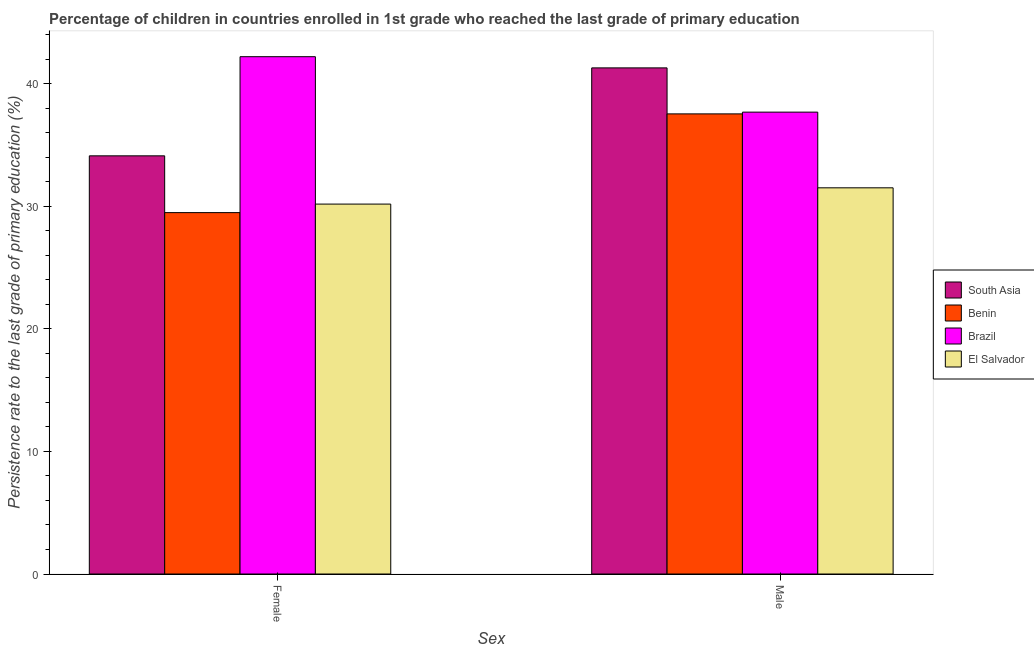Are the number of bars per tick equal to the number of legend labels?
Ensure brevity in your answer.  Yes. Are the number of bars on each tick of the X-axis equal?
Ensure brevity in your answer.  Yes. What is the label of the 2nd group of bars from the left?
Your answer should be compact. Male. What is the persistence rate of female students in El Salvador?
Provide a short and direct response. 30.19. Across all countries, what is the maximum persistence rate of male students?
Offer a terse response. 41.31. Across all countries, what is the minimum persistence rate of female students?
Provide a succinct answer. 29.5. In which country was the persistence rate of male students maximum?
Give a very brief answer. South Asia. In which country was the persistence rate of male students minimum?
Your answer should be compact. El Salvador. What is the total persistence rate of female students in the graph?
Provide a short and direct response. 136.04. What is the difference between the persistence rate of female students in Benin and that in Brazil?
Give a very brief answer. -12.73. What is the difference between the persistence rate of male students in Brazil and the persistence rate of female students in South Asia?
Give a very brief answer. 3.57. What is the average persistence rate of female students per country?
Provide a succinct answer. 34.01. What is the difference between the persistence rate of female students and persistence rate of male students in Brazil?
Keep it short and to the point. 4.53. In how many countries, is the persistence rate of female students greater than 26 %?
Give a very brief answer. 4. What is the ratio of the persistence rate of female students in South Asia to that in Benin?
Give a very brief answer. 1.16. In how many countries, is the persistence rate of male students greater than the average persistence rate of male students taken over all countries?
Your answer should be very brief. 3. What does the 4th bar from the right in Male represents?
Provide a succinct answer. South Asia. Are all the bars in the graph horizontal?
Your answer should be very brief. No. Are the values on the major ticks of Y-axis written in scientific E-notation?
Your response must be concise. No. Does the graph contain any zero values?
Your answer should be very brief. No. Does the graph contain grids?
Keep it short and to the point. No. How are the legend labels stacked?
Offer a very short reply. Vertical. What is the title of the graph?
Provide a short and direct response. Percentage of children in countries enrolled in 1st grade who reached the last grade of primary education. Does "Palau" appear as one of the legend labels in the graph?
Provide a succinct answer. No. What is the label or title of the X-axis?
Keep it short and to the point. Sex. What is the label or title of the Y-axis?
Make the answer very short. Persistence rate to the last grade of primary education (%). What is the Persistence rate to the last grade of primary education (%) of South Asia in Female?
Your answer should be very brief. 34.13. What is the Persistence rate to the last grade of primary education (%) of Benin in Female?
Your response must be concise. 29.5. What is the Persistence rate to the last grade of primary education (%) of Brazil in Female?
Offer a terse response. 42.22. What is the Persistence rate to the last grade of primary education (%) of El Salvador in Female?
Offer a terse response. 30.19. What is the Persistence rate to the last grade of primary education (%) in South Asia in Male?
Give a very brief answer. 41.31. What is the Persistence rate to the last grade of primary education (%) in Benin in Male?
Provide a short and direct response. 37.55. What is the Persistence rate to the last grade of primary education (%) of Brazil in Male?
Your response must be concise. 37.7. What is the Persistence rate to the last grade of primary education (%) of El Salvador in Male?
Offer a very short reply. 31.52. Across all Sex, what is the maximum Persistence rate to the last grade of primary education (%) of South Asia?
Ensure brevity in your answer.  41.31. Across all Sex, what is the maximum Persistence rate to the last grade of primary education (%) of Benin?
Offer a terse response. 37.55. Across all Sex, what is the maximum Persistence rate to the last grade of primary education (%) in Brazil?
Offer a terse response. 42.22. Across all Sex, what is the maximum Persistence rate to the last grade of primary education (%) in El Salvador?
Your response must be concise. 31.52. Across all Sex, what is the minimum Persistence rate to the last grade of primary education (%) of South Asia?
Keep it short and to the point. 34.13. Across all Sex, what is the minimum Persistence rate to the last grade of primary education (%) of Benin?
Your response must be concise. 29.5. Across all Sex, what is the minimum Persistence rate to the last grade of primary education (%) in Brazil?
Provide a short and direct response. 37.7. Across all Sex, what is the minimum Persistence rate to the last grade of primary education (%) of El Salvador?
Make the answer very short. 30.19. What is the total Persistence rate to the last grade of primary education (%) of South Asia in the graph?
Offer a terse response. 75.44. What is the total Persistence rate to the last grade of primary education (%) in Benin in the graph?
Give a very brief answer. 67.05. What is the total Persistence rate to the last grade of primary education (%) in Brazil in the graph?
Your response must be concise. 79.92. What is the total Persistence rate to the last grade of primary education (%) in El Salvador in the graph?
Your answer should be compact. 61.71. What is the difference between the Persistence rate to the last grade of primary education (%) in South Asia in Female and that in Male?
Ensure brevity in your answer.  -7.18. What is the difference between the Persistence rate to the last grade of primary education (%) in Benin in Female and that in Male?
Offer a very short reply. -8.06. What is the difference between the Persistence rate to the last grade of primary education (%) in Brazil in Female and that in Male?
Provide a short and direct response. 4.53. What is the difference between the Persistence rate to the last grade of primary education (%) in El Salvador in Female and that in Male?
Your answer should be compact. -1.33. What is the difference between the Persistence rate to the last grade of primary education (%) of South Asia in Female and the Persistence rate to the last grade of primary education (%) of Benin in Male?
Your answer should be compact. -3.42. What is the difference between the Persistence rate to the last grade of primary education (%) of South Asia in Female and the Persistence rate to the last grade of primary education (%) of Brazil in Male?
Provide a succinct answer. -3.57. What is the difference between the Persistence rate to the last grade of primary education (%) in South Asia in Female and the Persistence rate to the last grade of primary education (%) in El Salvador in Male?
Offer a very short reply. 2.61. What is the difference between the Persistence rate to the last grade of primary education (%) in Benin in Female and the Persistence rate to the last grade of primary education (%) in Brazil in Male?
Ensure brevity in your answer.  -8.2. What is the difference between the Persistence rate to the last grade of primary education (%) of Benin in Female and the Persistence rate to the last grade of primary education (%) of El Salvador in Male?
Keep it short and to the point. -2.02. What is the difference between the Persistence rate to the last grade of primary education (%) in Brazil in Female and the Persistence rate to the last grade of primary education (%) in El Salvador in Male?
Make the answer very short. 10.7. What is the average Persistence rate to the last grade of primary education (%) of South Asia per Sex?
Your response must be concise. 37.72. What is the average Persistence rate to the last grade of primary education (%) of Benin per Sex?
Ensure brevity in your answer.  33.53. What is the average Persistence rate to the last grade of primary education (%) in Brazil per Sex?
Provide a short and direct response. 39.96. What is the average Persistence rate to the last grade of primary education (%) of El Salvador per Sex?
Make the answer very short. 30.86. What is the difference between the Persistence rate to the last grade of primary education (%) in South Asia and Persistence rate to the last grade of primary education (%) in Benin in Female?
Keep it short and to the point. 4.63. What is the difference between the Persistence rate to the last grade of primary education (%) in South Asia and Persistence rate to the last grade of primary education (%) in Brazil in Female?
Provide a succinct answer. -8.09. What is the difference between the Persistence rate to the last grade of primary education (%) in South Asia and Persistence rate to the last grade of primary education (%) in El Salvador in Female?
Provide a succinct answer. 3.94. What is the difference between the Persistence rate to the last grade of primary education (%) in Benin and Persistence rate to the last grade of primary education (%) in Brazil in Female?
Make the answer very short. -12.73. What is the difference between the Persistence rate to the last grade of primary education (%) of Benin and Persistence rate to the last grade of primary education (%) of El Salvador in Female?
Give a very brief answer. -0.7. What is the difference between the Persistence rate to the last grade of primary education (%) in Brazil and Persistence rate to the last grade of primary education (%) in El Salvador in Female?
Give a very brief answer. 12.03. What is the difference between the Persistence rate to the last grade of primary education (%) in South Asia and Persistence rate to the last grade of primary education (%) in Benin in Male?
Provide a short and direct response. 3.75. What is the difference between the Persistence rate to the last grade of primary education (%) of South Asia and Persistence rate to the last grade of primary education (%) of Brazil in Male?
Make the answer very short. 3.61. What is the difference between the Persistence rate to the last grade of primary education (%) of South Asia and Persistence rate to the last grade of primary education (%) of El Salvador in Male?
Provide a short and direct response. 9.79. What is the difference between the Persistence rate to the last grade of primary education (%) in Benin and Persistence rate to the last grade of primary education (%) in Brazil in Male?
Offer a terse response. -0.14. What is the difference between the Persistence rate to the last grade of primary education (%) in Benin and Persistence rate to the last grade of primary education (%) in El Salvador in Male?
Ensure brevity in your answer.  6.03. What is the difference between the Persistence rate to the last grade of primary education (%) of Brazil and Persistence rate to the last grade of primary education (%) of El Salvador in Male?
Your answer should be compact. 6.18. What is the ratio of the Persistence rate to the last grade of primary education (%) of South Asia in Female to that in Male?
Your answer should be compact. 0.83. What is the ratio of the Persistence rate to the last grade of primary education (%) of Benin in Female to that in Male?
Offer a very short reply. 0.79. What is the ratio of the Persistence rate to the last grade of primary education (%) of Brazil in Female to that in Male?
Offer a terse response. 1.12. What is the ratio of the Persistence rate to the last grade of primary education (%) of El Salvador in Female to that in Male?
Your answer should be compact. 0.96. What is the difference between the highest and the second highest Persistence rate to the last grade of primary education (%) of South Asia?
Provide a short and direct response. 7.18. What is the difference between the highest and the second highest Persistence rate to the last grade of primary education (%) in Benin?
Your answer should be compact. 8.06. What is the difference between the highest and the second highest Persistence rate to the last grade of primary education (%) of Brazil?
Ensure brevity in your answer.  4.53. What is the difference between the highest and the second highest Persistence rate to the last grade of primary education (%) in El Salvador?
Provide a succinct answer. 1.33. What is the difference between the highest and the lowest Persistence rate to the last grade of primary education (%) of South Asia?
Your response must be concise. 7.18. What is the difference between the highest and the lowest Persistence rate to the last grade of primary education (%) in Benin?
Your answer should be compact. 8.06. What is the difference between the highest and the lowest Persistence rate to the last grade of primary education (%) of Brazil?
Your response must be concise. 4.53. What is the difference between the highest and the lowest Persistence rate to the last grade of primary education (%) in El Salvador?
Keep it short and to the point. 1.33. 